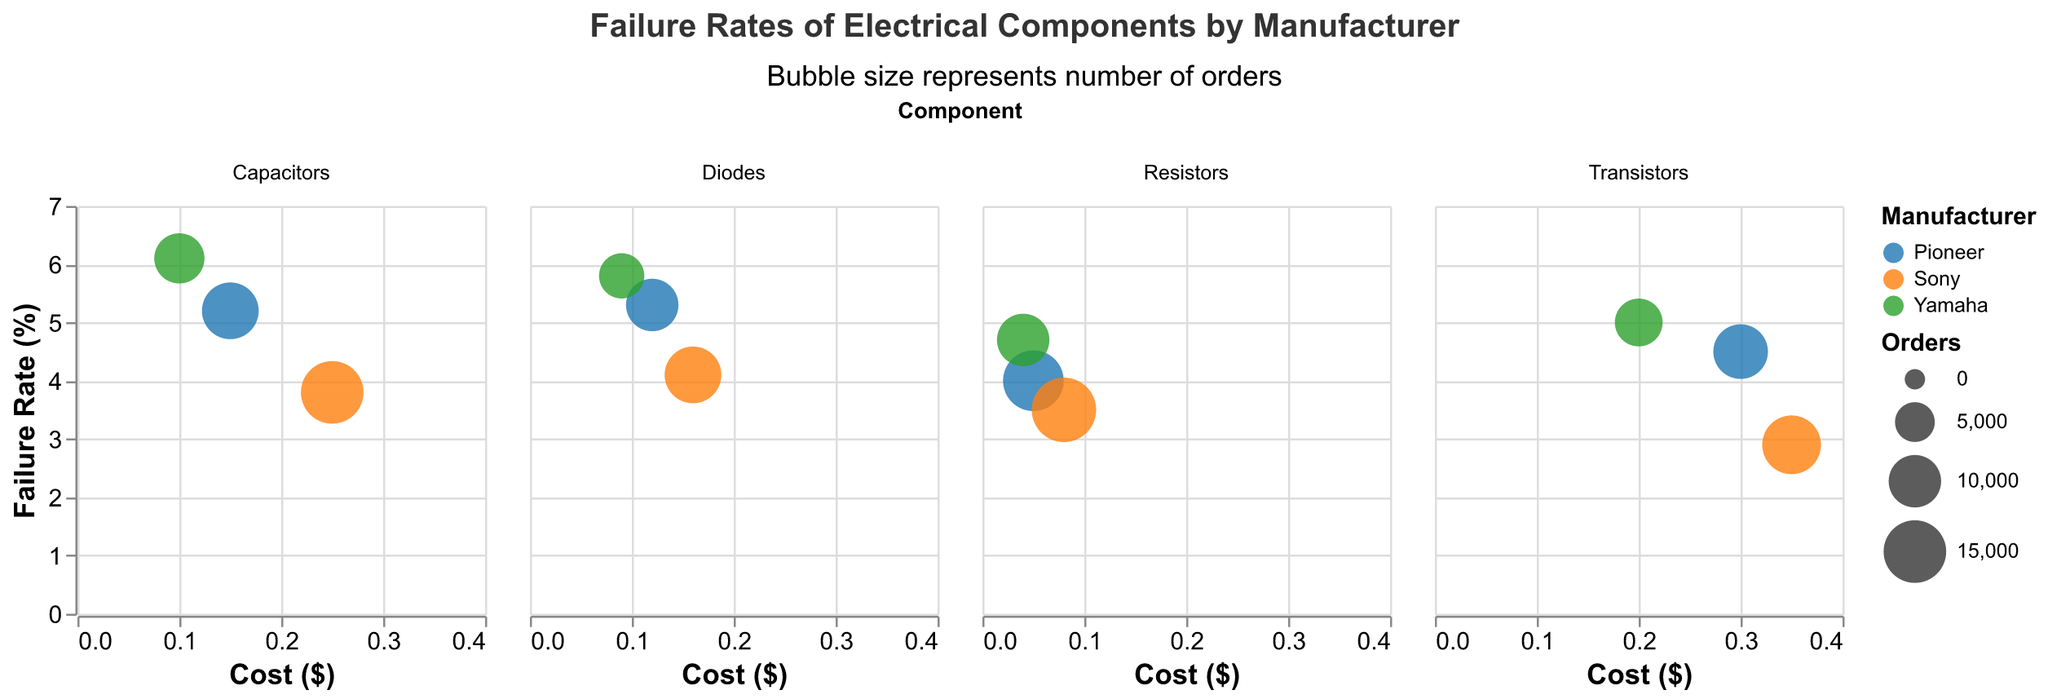Which manufacturer has the lowest failure rate for capacitors? Looking at the subplot for capacitors, find the bubble with the lowest vertical position, which corresponds to the failure rate. The lowest point is by Sony.
Answer: Sony Among the resistors, which manufacturer's component has the highest cost? In the resistors subplot, identify the bubble farthest to the right, representing the highest cost. The bubble corresponding to Sony is the farthest right.
Answer: Sony What is the failure rate and cost of Yamaha's transistors? Locate Yamaha’s bubble in the transistors subplot. By referring to the tooltip or the axes, you can determine that the failure rate is 5.0% and the cost is $0.20.
Answer: 5.0%, $0.20 How many orders of diodes did Sony receive? Find Sony’s bubble in the diodes subplot. The size of the bubble represents the number of orders, and referring to the tooltip reveals Sony had 12,000 orders.
Answer: 12,000 Compare the costs of capacitors for Pioneer and Yamaha. Which one is cheaper? In the capacitors subplot, check the horizontal positions of the bubbles for Pioneer and Yamaha. Pioneer's cost is $0.15, and Yamaha's cost is $0.10. Yamaha's capacitors are cheaper.
Answer: Yamaha Which manufacturer has the highest overall failure rate for any component? Review all subplots to locate the highest position of any manufacturer’s bubble. Yamaha’s capacitors exhibit the highest failure rate at 6.1%.
Answer: Yamaha Between Pioneer's and Sony's transistors, which has a lower failure rate and what are their respective rates? Check both manufacturer's bubbles in the transistors subplot, noting their vertical positions. Pioneer's failure rate is 4.5%, and Sony's is 2.9%. Sony's transistors have a lower failure rate.
Answer: Sony, 4.5% and 2.9% What's the average cost of capacitors across all manufacturers? The costs of capacitors are $0.15 (Pioneer), $0.25 (Sony), and $0.10 (Yamaha). The average cost is calculated as (0.15 + 0.25 + 0.10) / 3 = 0.1667.
Answer: $0.167 Is there any component where all manufacturers have similar failure rates within a 1% range? Review all subplots to find components where the difference between the highest and lowest failure rates is less than or equal to 1%. For transistors, the failure rates are 4.5% (Pioneer), 2.9% (Sony), and 5.0% (Yamaha), which are not within a 1% range. However, the resistors’ failure rates are 4.0% (Pioneer), 3.5% (Sony), and 4.7% (Yamaha), so within 1.2%. The closest range within 1.2% only; none are within a strict 1%.
Answer: None within 1% range Which electrical component has the highest number of total orders across all manufacturers? Sum the orders for each component across manufacturers: Capacitors: 12000 + 15000 + 9000 = 36000, Transistors: 11000 + 13000 + 8000 = 32000, Resistors: 14000 + 16000 + 10000 = 40000, Diodes: 10000 + 12000 + 7000 = 29000. Resistors have the highest overall orders.
Answer: Resistors 